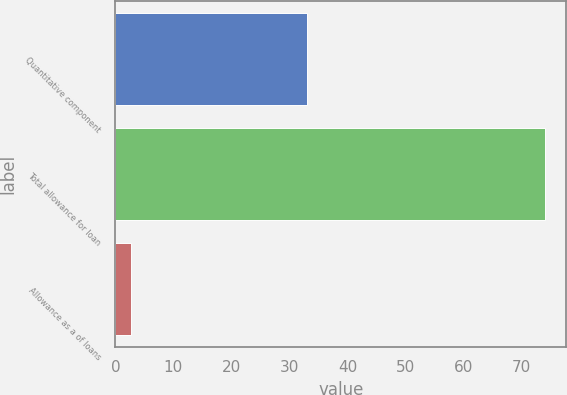Convert chart. <chart><loc_0><loc_0><loc_500><loc_500><bar_chart><fcel>Quantitative component<fcel>Total allowance for loan<fcel>Allowance as a of loans<nl><fcel>33<fcel>74<fcel>2.7<nl></chart> 